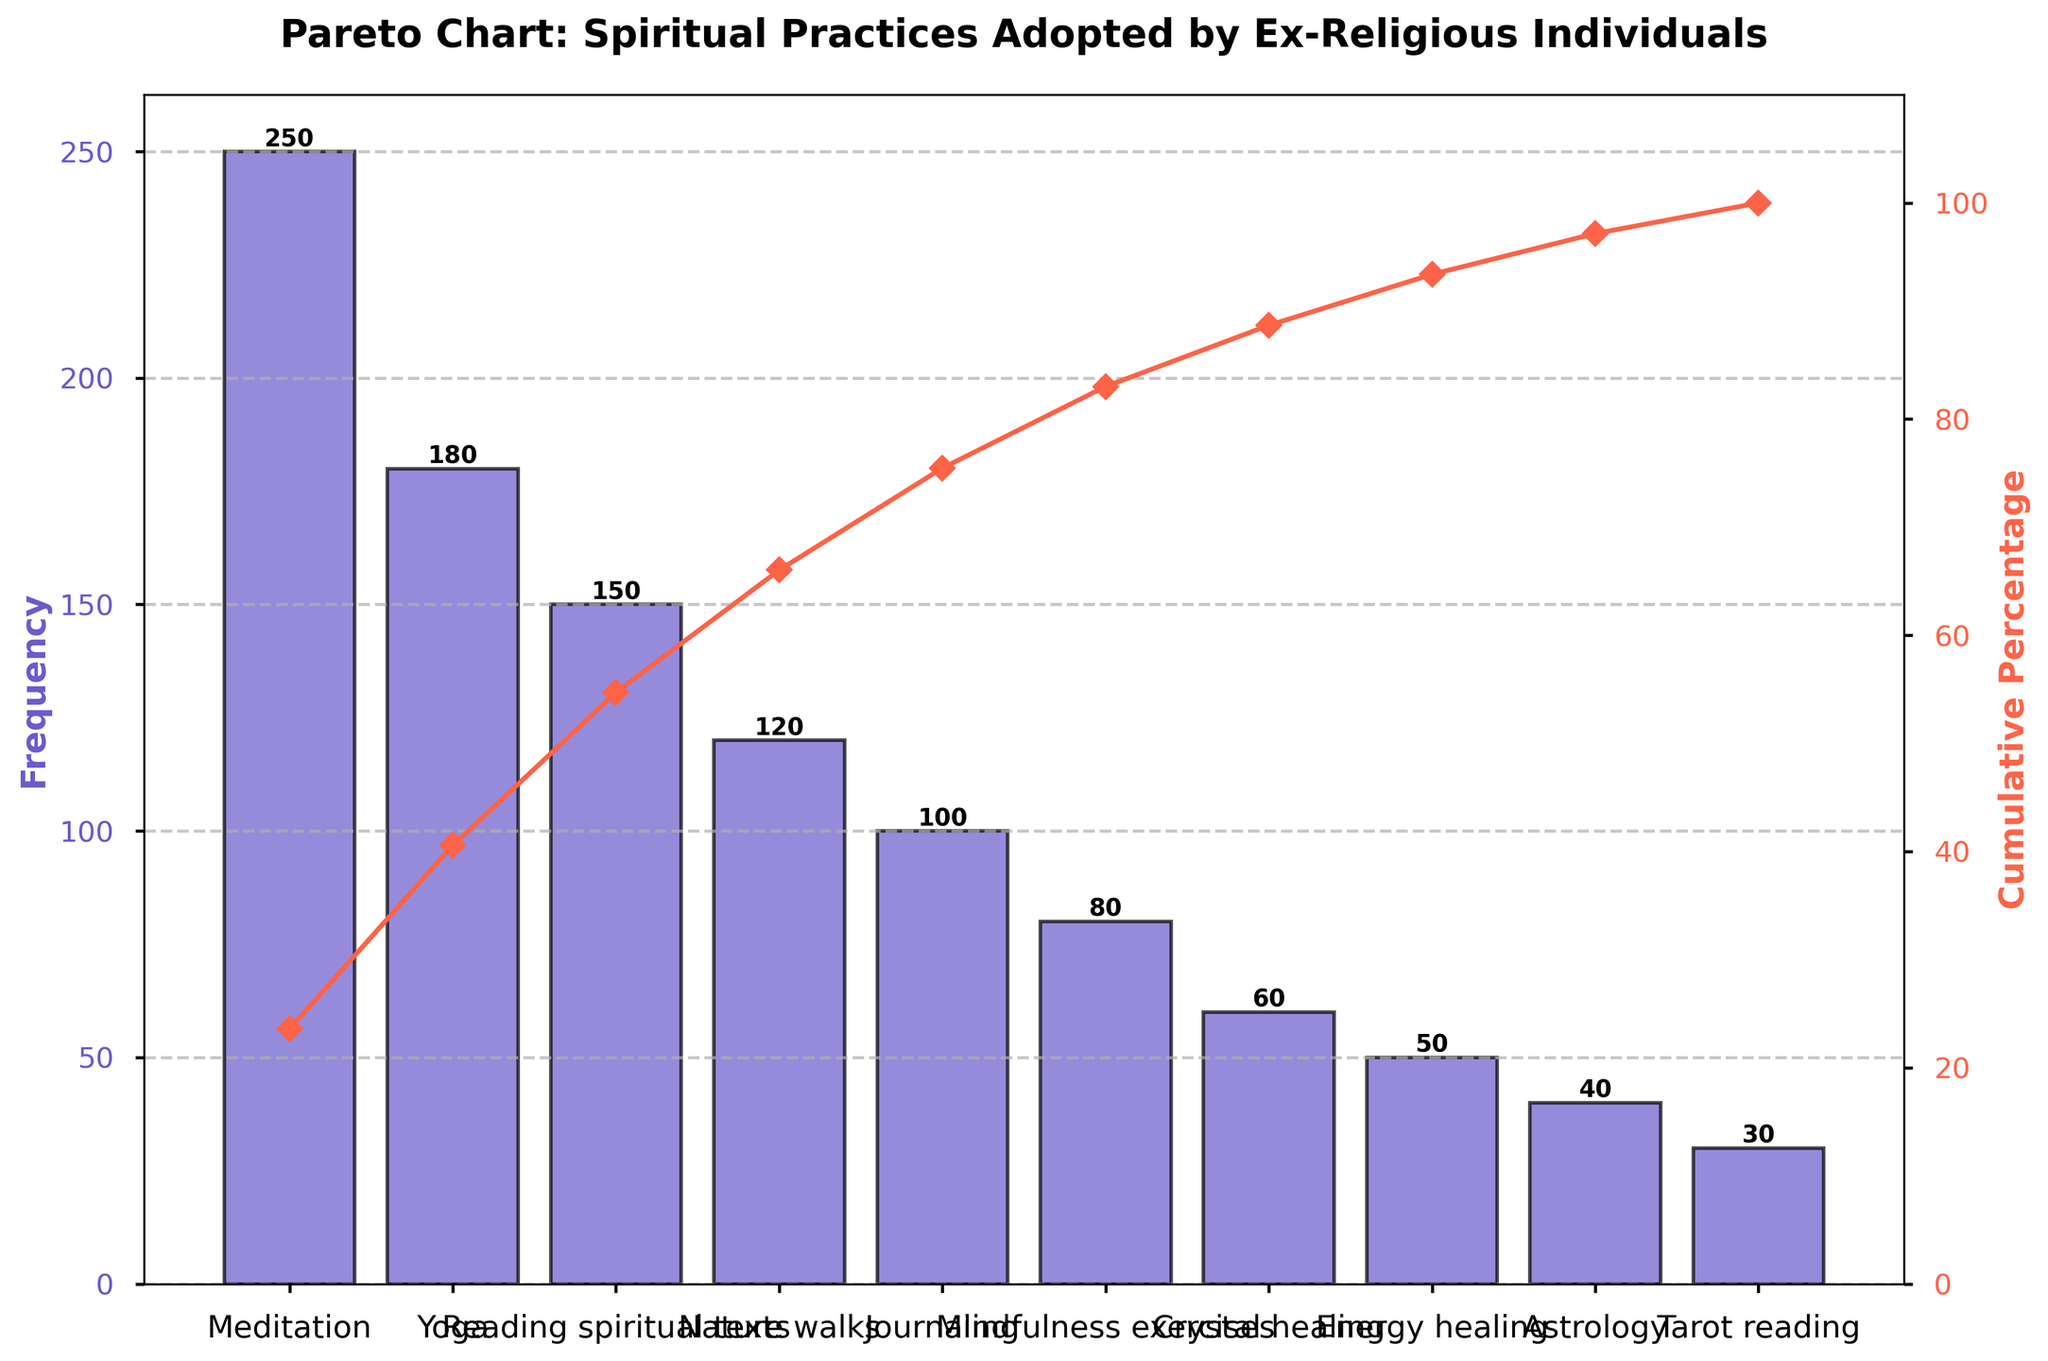What is the title of the figure? The title of the figure is located at the top center and is styled in bold with a font size of 16. Simply reading this text provides the answer.
Answer: Pareto Chart: Spiritual Practices Adopted by Ex-Religious Individuals What practice has the highest frequency? By looking at the height of the bars, the tallest bar indicates the practice with the highest frequency. The label on the x-axis corresponding to this bar shows "Meditation."
Answer: Meditation What is the cumulative percentage for the first three practices? Identify the cumulative percentages of "Meditation," "Yoga," and "Reading spiritual texts." These values need to be read from the secondary y-axis adjacent to the red line. Summing them up will provide the cumulative percentage.
Answer: Approximately 57.6% Which practice is more popular, Yoga or Tarot reading? By comparing the heights of bars and their respective frequencies, the bar for "Yoga" is significantly taller and represents a frequency of 180, whereas "Tarot reading" has a frequency of 30.
Answer: Yoga How many practices have a frequency of at least 100? Count the number of practices that reach or exceed the 100 mark on the primary y-axis by examining the bars' heights.
Answer: 5 What percentage of practices account for approximately 70% of the total frequency? The red line shows the cumulative percentage. Trace the point closest to 70% and count the practices up to this point on the x-axis.
Answer: 4 practices What is the difference in frequency between Nature walks and Energy healing? Find the bars for "Nature walks" and "Energy healing," note their respective frequencies (120 and 50), and subtract the smaller value from the larger one.
Answer: 70 What is the cumulative percentage of "Astrology"? Locate the bar for "Astrology" and read the corresponding cumulative percentage from the secondary y-axis where the red line meets this point.
Answer: Approximately 96% What is the frequency for Mindfulness exercises? Identify the bar labeled "Mindfulness exercises" on the x-axis and read its height or the value written above it.
Answer: 80 